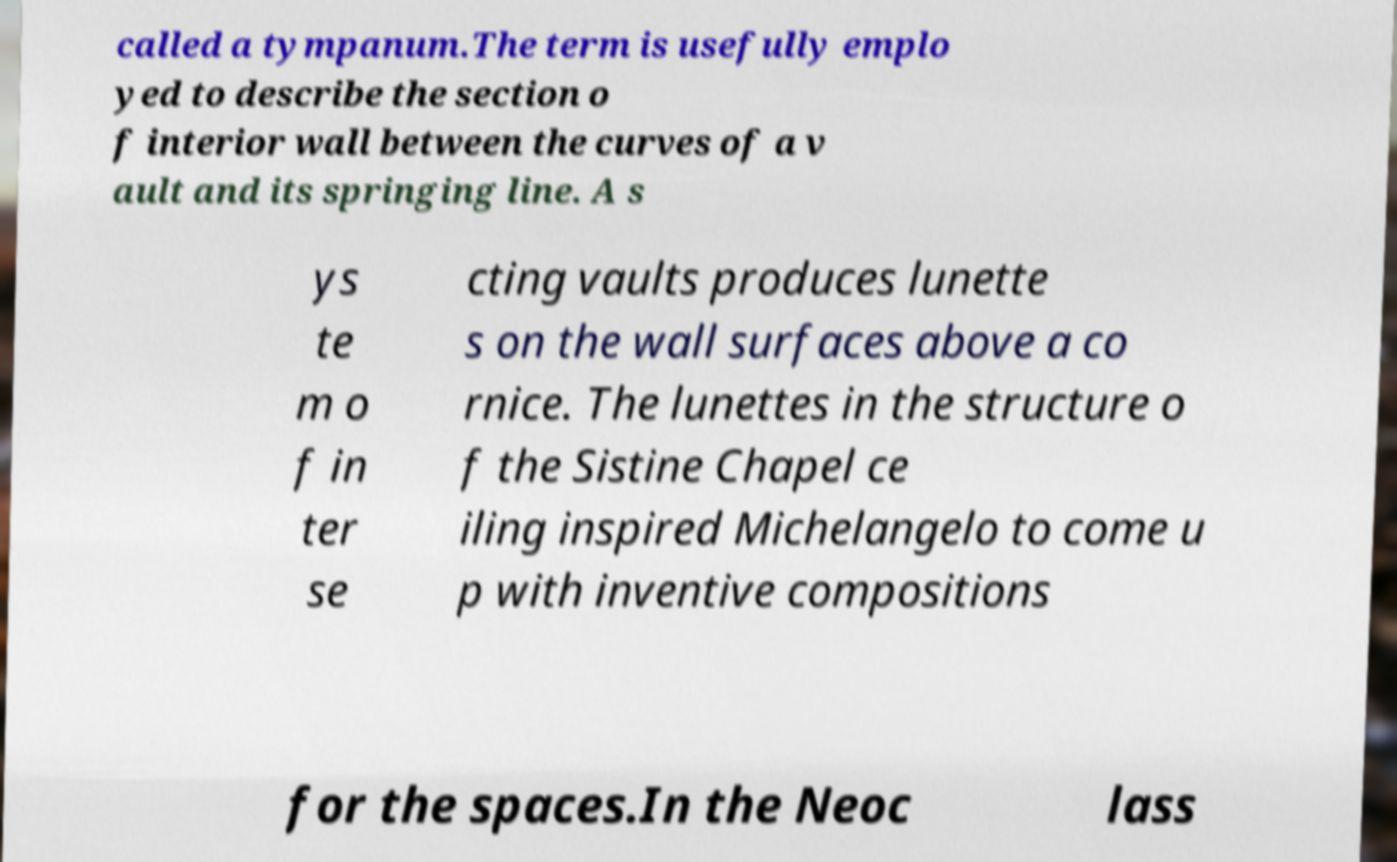Please identify and transcribe the text found in this image. called a tympanum.The term is usefully emplo yed to describe the section o f interior wall between the curves of a v ault and its springing line. A s ys te m o f in ter se cting vaults produces lunette s on the wall surfaces above a co rnice. The lunettes in the structure o f the Sistine Chapel ce iling inspired Michelangelo to come u p with inventive compositions for the spaces.In the Neoc lass 